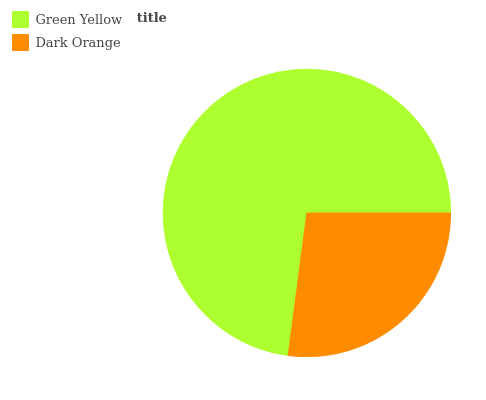Is Dark Orange the minimum?
Answer yes or no. Yes. Is Green Yellow the maximum?
Answer yes or no. Yes. Is Dark Orange the maximum?
Answer yes or no. No. Is Green Yellow greater than Dark Orange?
Answer yes or no. Yes. Is Dark Orange less than Green Yellow?
Answer yes or no. Yes. Is Dark Orange greater than Green Yellow?
Answer yes or no. No. Is Green Yellow less than Dark Orange?
Answer yes or no. No. Is Green Yellow the high median?
Answer yes or no. Yes. Is Dark Orange the low median?
Answer yes or no. Yes. Is Dark Orange the high median?
Answer yes or no. No. Is Green Yellow the low median?
Answer yes or no. No. 